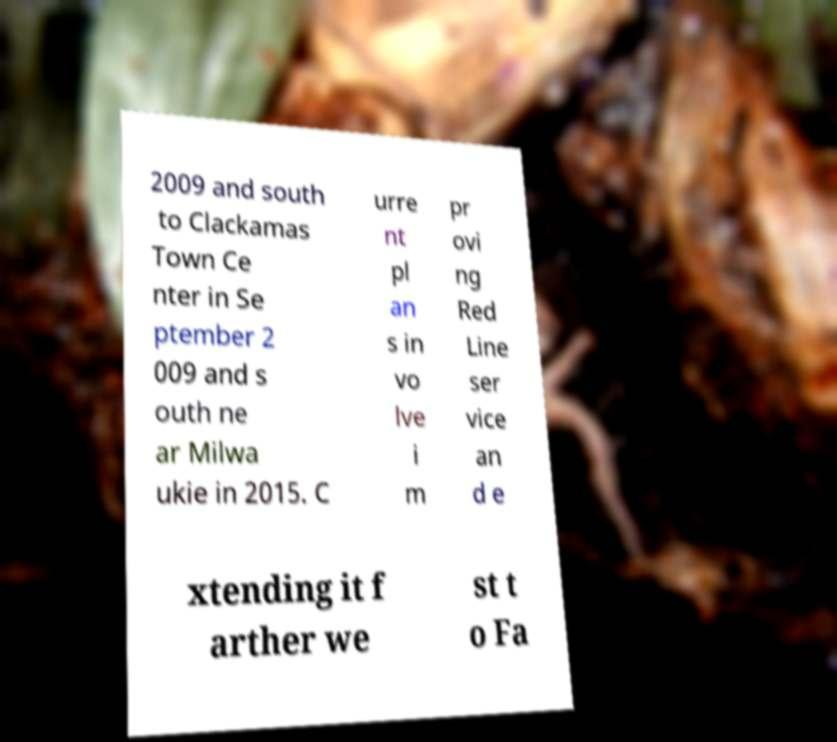Can you read and provide the text displayed in the image?This photo seems to have some interesting text. Can you extract and type it out for me? 2009 and south to Clackamas Town Ce nter in Se ptember 2 009 and s outh ne ar Milwa ukie in 2015. C urre nt pl an s in vo lve i m pr ovi ng Red Line ser vice an d e xtending it f arther we st t o Fa 